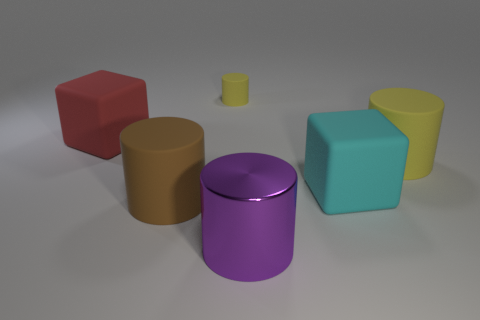Subtract all metal cylinders. How many cylinders are left? 3 Subtract all brown cylinders. How many cylinders are left? 3 Add 1 yellow objects. How many objects exist? 7 Subtract all blocks. How many objects are left? 4 Subtract all blue cylinders. How many red cubes are left? 1 Subtract 0 blue balls. How many objects are left? 6 Subtract 2 cylinders. How many cylinders are left? 2 Subtract all blue cylinders. Subtract all yellow spheres. How many cylinders are left? 4 Subtract all large matte blocks. Subtract all large matte cylinders. How many objects are left? 2 Add 3 brown objects. How many brown objects are left? 4 